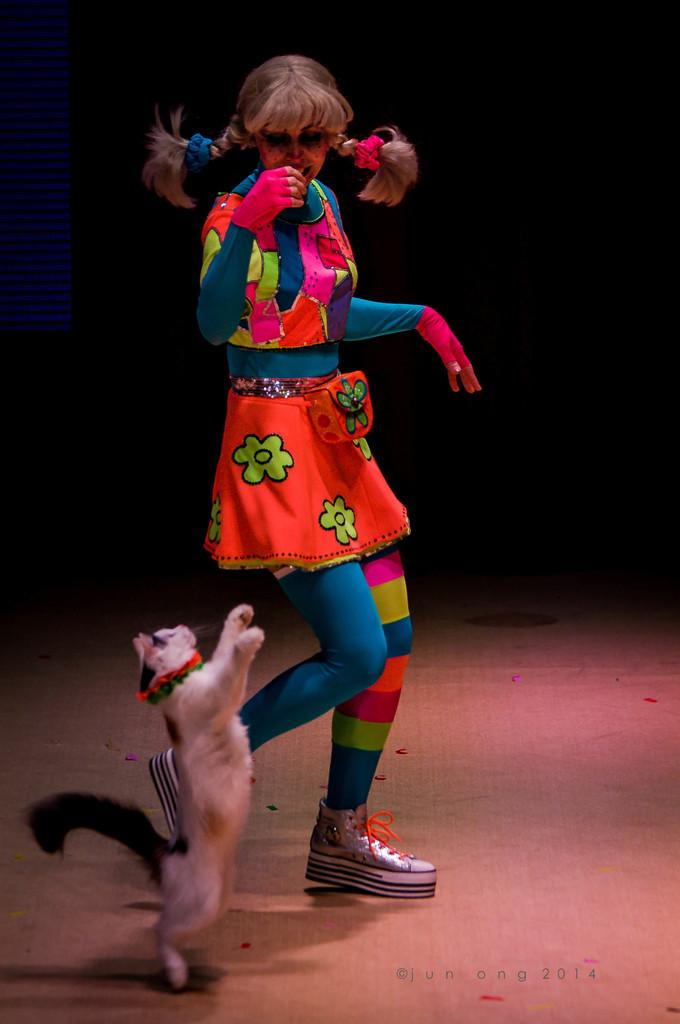What is the person in the image doing? There is a person in a costume dancing in the image. What animal is also present in the image? There is a cat standing on two legs in the image. Where can text be found in the image? Text can be found in the bottom right of the image. How does the person in the image ride the bike while coughing? There is no bike or coughing person present in the image; it features a person in a costume dancing and a cat standing on two legs. 